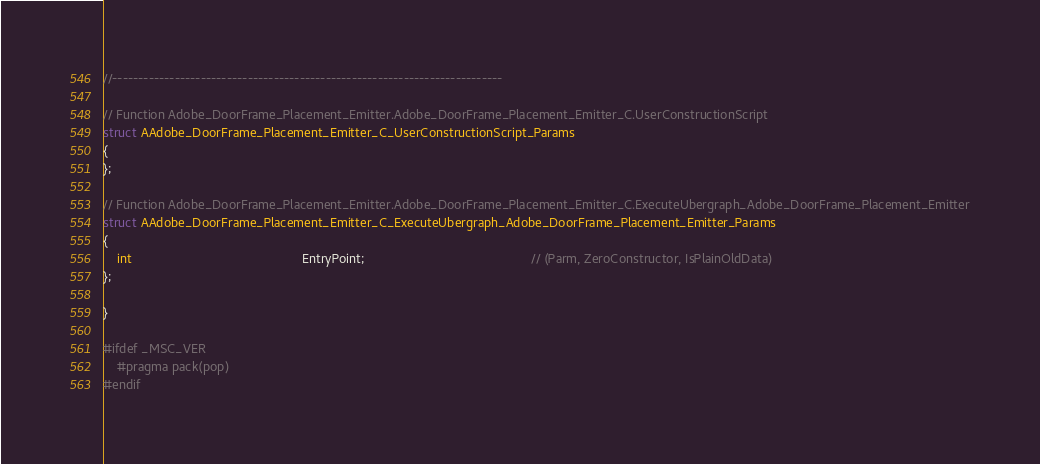Convert code to text. <code><loc_0><loc_0><loc_500><loc_500><_C++_>//---------------------------------------------------------------------------

// Function Adobe_DoorFrame_Placement_Emitter.Adobe_DoorFrame_Placement_Emitter_C.UserConstructionScript
struct AAdobe_DoorFrame_Placement_Emitter_C_UserConstructionScript_Params
{
};

// Function Adobe_DoorFrame_Placement_Emitter.Adobe_DoorFrame_Placement_Emitter_C.ExecuteUbergraph_Adobe_DoorFrame_Placement_Emitter
struct AAdobe_DoorFrame_Placement_Emitter_C_ExecuteUbergraph_Adobe_DoorFrame_Placement_Emitter_Params
{
	int                                                EntryPoint;                                               // (Parm, ZeroConstructor, IsPlainOldData)
};

}

#ifdef _MSC_VER
	#pragma pack(pop)
#endif
</code> 